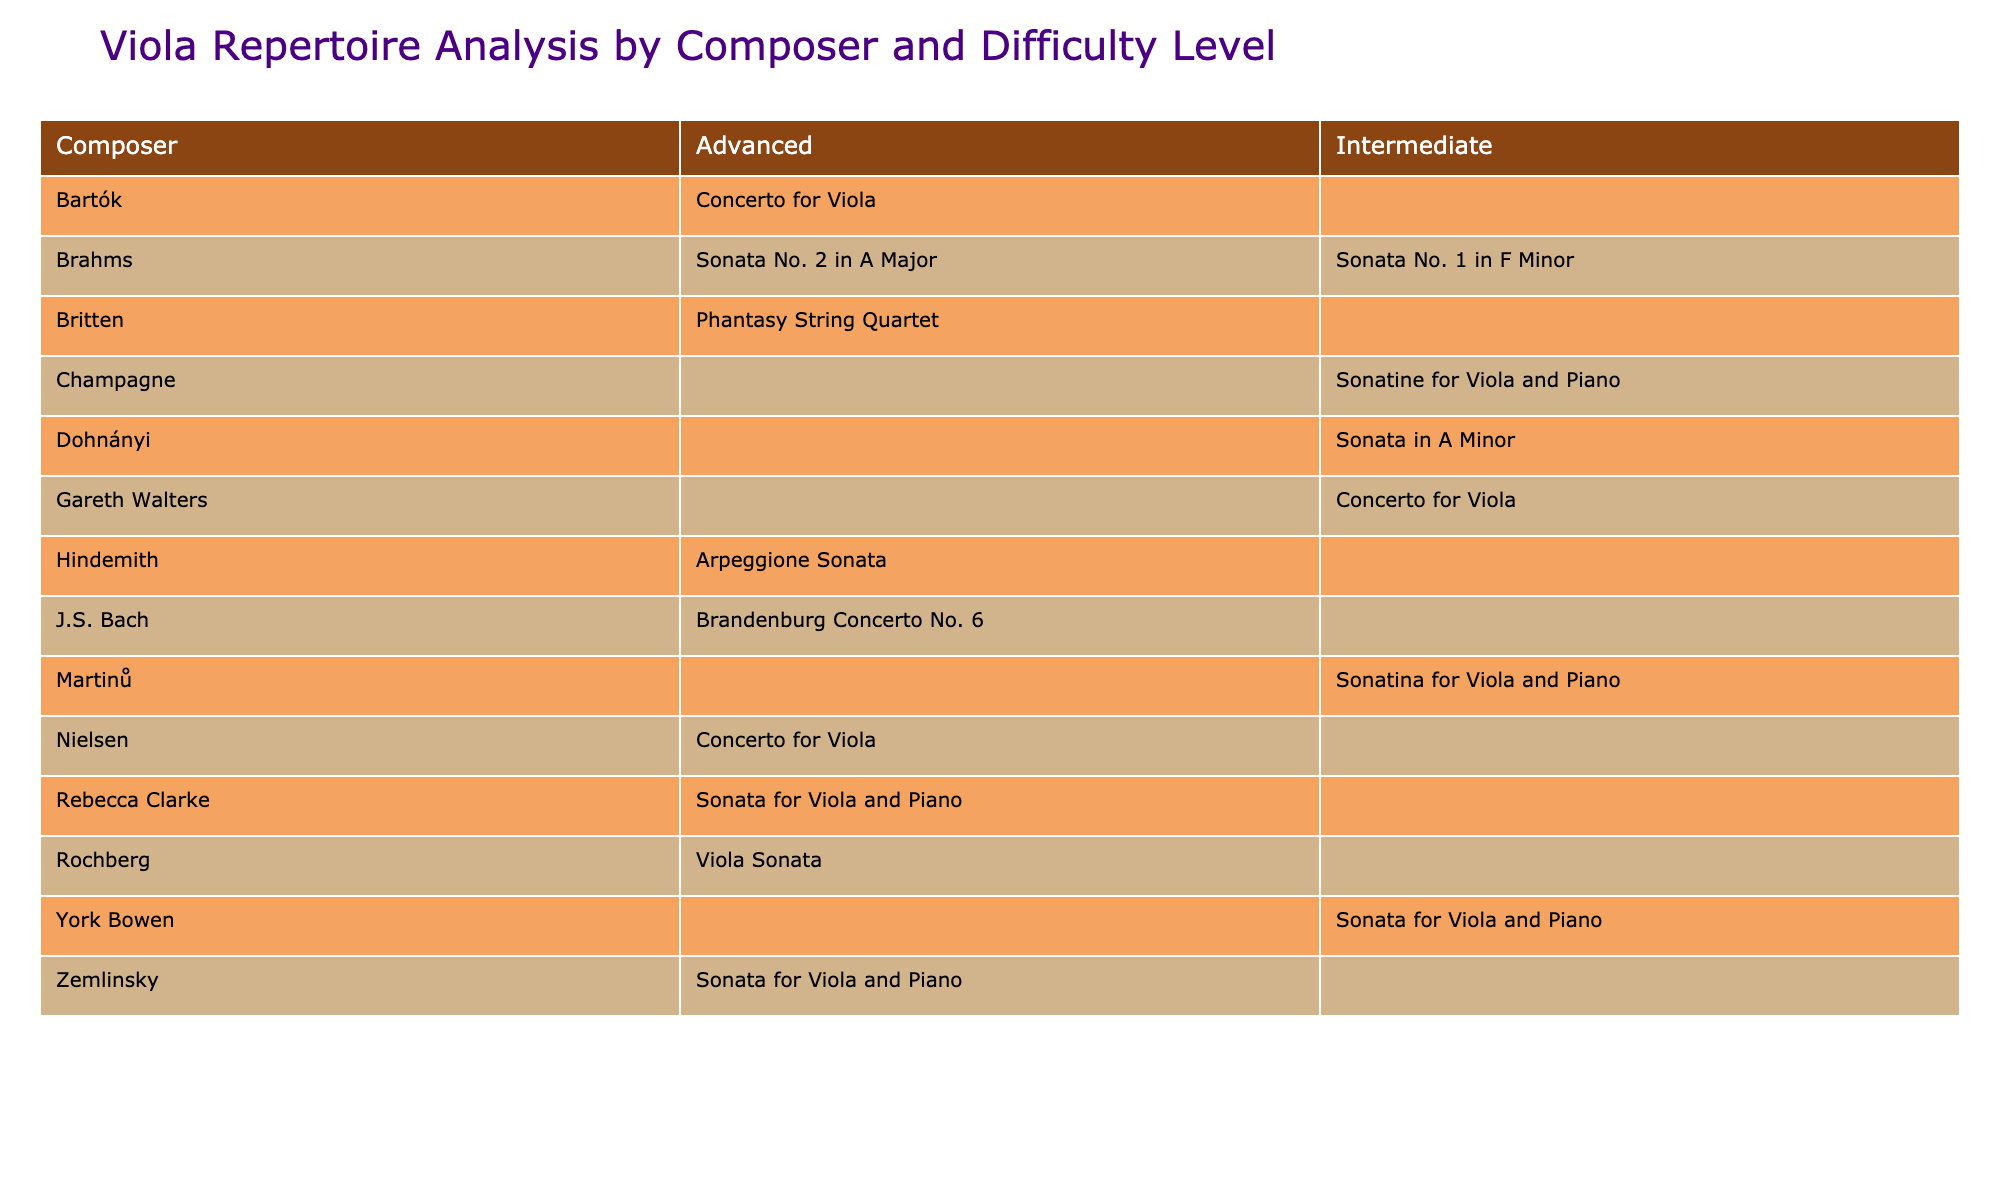What compositions did Brahms write for viola? According to the table, Brahms composed two pieces for viola: "Sonata No. 1 in F Minor" and "Sonata No. 2 in A Major." Both of these are listed under the composer Brahms in the table.
Answer: Sonata No. 1 in F Minor, Sonata No. 2 in A Major How many advanced repertoires are composed by Bartók? The table shows that Bartók composed one piece for viola, which is the "Concerto for Viola," categorized as advanced. Thus, there's one advanced piece by Bartók.
Answer: 1 Is there any intermediate repertoire composed by Hindemith? By checking the table, Hindemith has only one piece listed: the "Arpeggione Sonata," which is classified as advanced. Therefore, there is no intermediate repertoire composed by Hindemith.
Answer: No Which composer has the most pieces listed in the advanced category? By examining the table, we can see that composers such as Bartók, Hindemith, Rebecca Clarke, Rochberg, Britten, Zemlinsky, and Nielsen each have one advanced piece. However, no composer has multiple works listed in the advanced category, indicating that there's a tie among several composers.
Answer: None What is the total number of intermediate compositions in the table? The table indicates that there are five intermediate pieces: "Sonatine for Viola and Piano" by Champagne, "Concerto for Viola" by Gareth Walters, "Sonata in A Minor" by Dohnányi, "Sonata for Viola and Piano" by York Bowen, and "Sonatina for Viola and Piano" by Martinů. Therefore, we sum them up to find a total of five intermediate pieces.
Answer: 5 How many composers created works categorized as both intermediate and advanced? Checking the table, we find composers such as Brahms (2 intermediate, 2 advanced), Hindemith (0 intermediate, 1 advanced), Clarke (0 intermediate, 1 advanced), and others. The only composers listed who have works in both categories are Brahms (with both intermediate and advanced compositions). This means just one composer fits this criterion.
Answer: 1 Which piece is the only one specifically categorized as intermediate by Walters? The table indicates that Gareth Walters composed just one piece, which is the "Concerto for Viola." This piece is specifically designated as intermediate.
Answer: Concerto for Viola Are there any pieces by composers that are not associated with both difficulty levels? From analyzing the table, we observe that composers like Bartók, Hindemith, and Zemlinsky have only advanced pieces, while others like Champagne and Dohnányi have only intermediate pieces. Therefore, there are multiple composers with compositions that are not present in both difficulty levels.
Answer: Yes Which two composers share the same difficulty level for their compositions? Looking at the intermediate category, both Champagne and Gareth Walters have their compositions in this level. Thus, the answer points to these two composers having shared difficulty levels in the intermediate category.
Answer: Champagne and Gareth Walters 